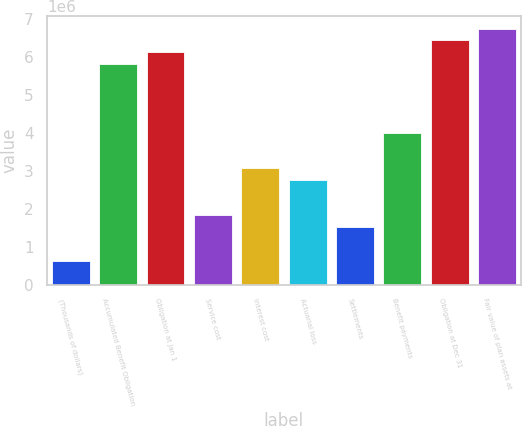Convert chart. <chart><loc_0><loc_0><loc_500><loc_500><bar_chart><fcel>(Thousands of dollars)<fcel>Accumulated Benefit Obligation<fcel>Obligation at Jan 1<fcel>Service cost<fcel>Interest cost<fcel>Actuarial loss<fcel>Settlements<fcel>Benefit payments<fcel>Obligation at Dec 31<fcel>Fair value of plan assets at<nl><fcel>612406<fcel>5.81783e+06<fcel>6.12403e+06<fcel>1.83721e+06<fcel>3.06202e+06<fcel>2.75581e+06<fcel>1.53101e+06<fcel>3.98062e+06<fcel>6.43023e+06<fcel>6.73643e+06<nl></chart> 